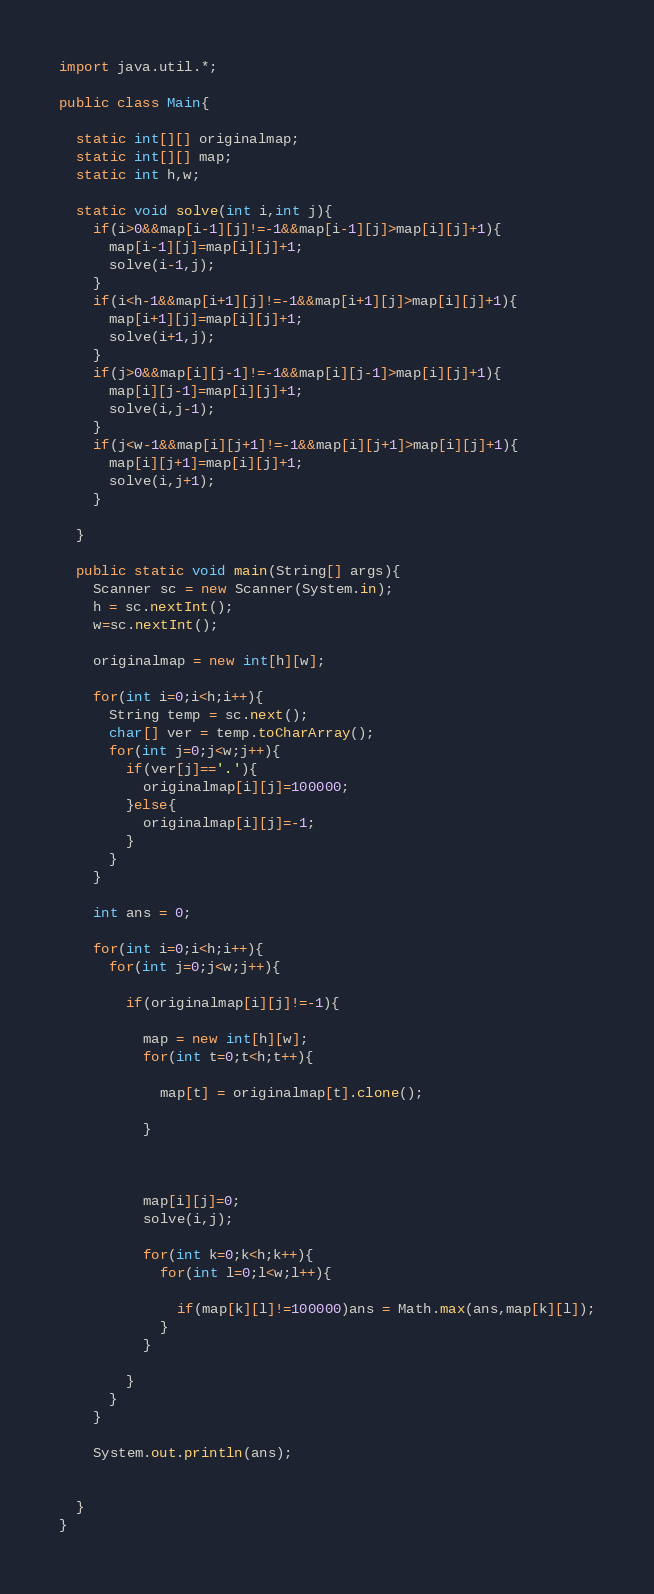<code> <loc_0><loc_0><loc_500><loc_500><_Java_>import java.util.*;

public class Main{
  
  static int[][] originalmap;
  static int[][] map;
  static int h,w;
  
  static void solve(int i,int j){
    if(i>0&&map[i-1][j]!=-1&&map[i-1][j]>map[i][j]+1){
      map[i-1][j]=map[i][j]+1;
      solve(i-1,j);
    }
    if(i<h-1&&map[i+1][j]!=-1&&map[i+1][j]>map[i][j]+1){
      map[i+1][j]=map[i][j]+1;
      solve(i+1,j);
    }
    if(j>0&&map[i][j-1]!=-1&&map[i][j-1]>map[i][j]+1){
      map[i][j-1]=map[i][j]+1;
      solve(i,j-1);
    }
    if(j<w-1&&map[i][j+1]!=-1&&map[i][j+1]>map[i][j]+1){
      map[i][j+1]=map[i][j]+1;
      solve(i,j+1);
    }
    
  }
  
  public static void main(String[] args){
    Scanner sc = new Scanner(System.in);
    h = sc.nextInt();
    w=sc.nextInt();
    
    originalmap = new int[h][w];
    
    for(int i=0;i<h;i++){
      String temp = sc.next();
      char[] ver = temp.toCharArray();
      for(int j=0;j<w;j++){
        if(ver[j]=='.'){
          originalmap[i][j]=100000;
        }else{
          originalmap[i][j]=-1;
        }
      }
    }
    
    int ans = 0;
    
    for(int i=0;i<h;i++){
      for(int j=0;j<w;j++){
        
        if(originalmap[i][j]!=-1){
          
          map = new int[h][w];
          for(int t=0;t<h;t++){
            
            map[t] = originalmap[t].clone();

          }
          

          
          map[i][j]=0;
          solve(i,j);

          for(int k=0;k<h;k++){
            for(int l=0;l<w;l++){
              
              if(map[k][l]!=100000)ans = Math.max(ans,map[k][l]);
            }
          }
          
        }
      }
    }
    
    System.out.println(ans);
    
    
  }
}
</code> 